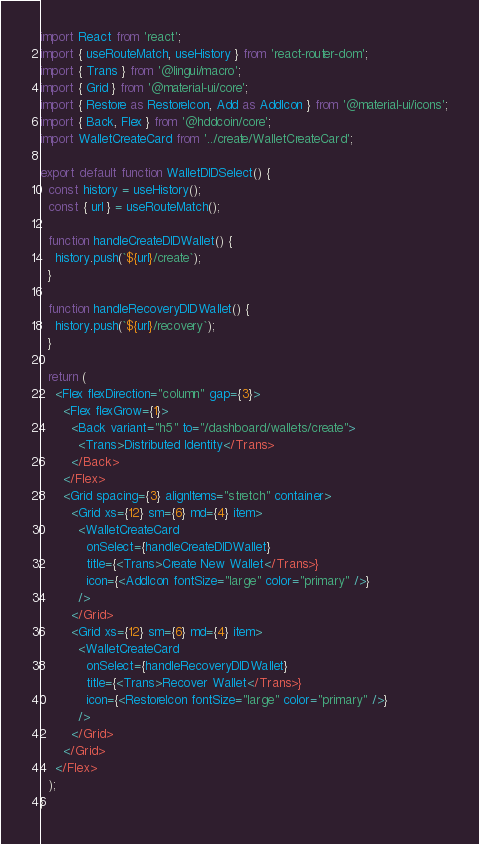<code> <loc_0><loc_0><loc_500><loc_500><_TypeScript_>import React from 'react';
import { useRouteMatch, useHistory } from 'react-router-dom';
import { Trans } from '@lingui/macro';
import { Grid } from '@material-ui/core';
import { Restore as RestoreIcon, Add as AddIcon } from '@material-ui/icons';
import { Back, Flex } from '@hddcoin/core';
import WalletCreateCard from '../create/WalletCreateCard';

export default function WalletDIDSelect() {
  const history = useHistory();
  const { url } = useRouteMatch();

  function handleCreateDIDWallet() {
    history.push(`${url}/create`);
  }

  function handleRecoveryDIDWallet() {
    history.push(`${url}/recovery`);
  }

  return (
    <Flex flexDirection="column" gap={3}>
      <Flex flexGrow={1}>
        <Back variant="h5" to="/dashboard/wallets/create">
          <Trans>Distributed Identity</Trans>
        </Back>
      </Flex>
      <Grid spacing={3} alignItems="stretch" container>
        <Grid xs={12} sm={6} md={4} item>
          <WalletCreateCard
            onSelect={handleCreateDIDWallet}
            title={<Trans>Create New Wallet</Trans>}
            icon={<AddIcon fontSize="large" color="primary" />}
          />
        </Grid>
        <Grid xs={12} sm={6} md={4} item>
          <WalletCreateCard
            onSelect={handleRecoveryDIDWallet}
            title={<Trans>Recover Wallet</Trans>}
            icon={<RestoreIcon fontSize="large" color="primary" />}
          />
        </Grid>
      </Grid>
    </Flex>
  );
}
</code> 